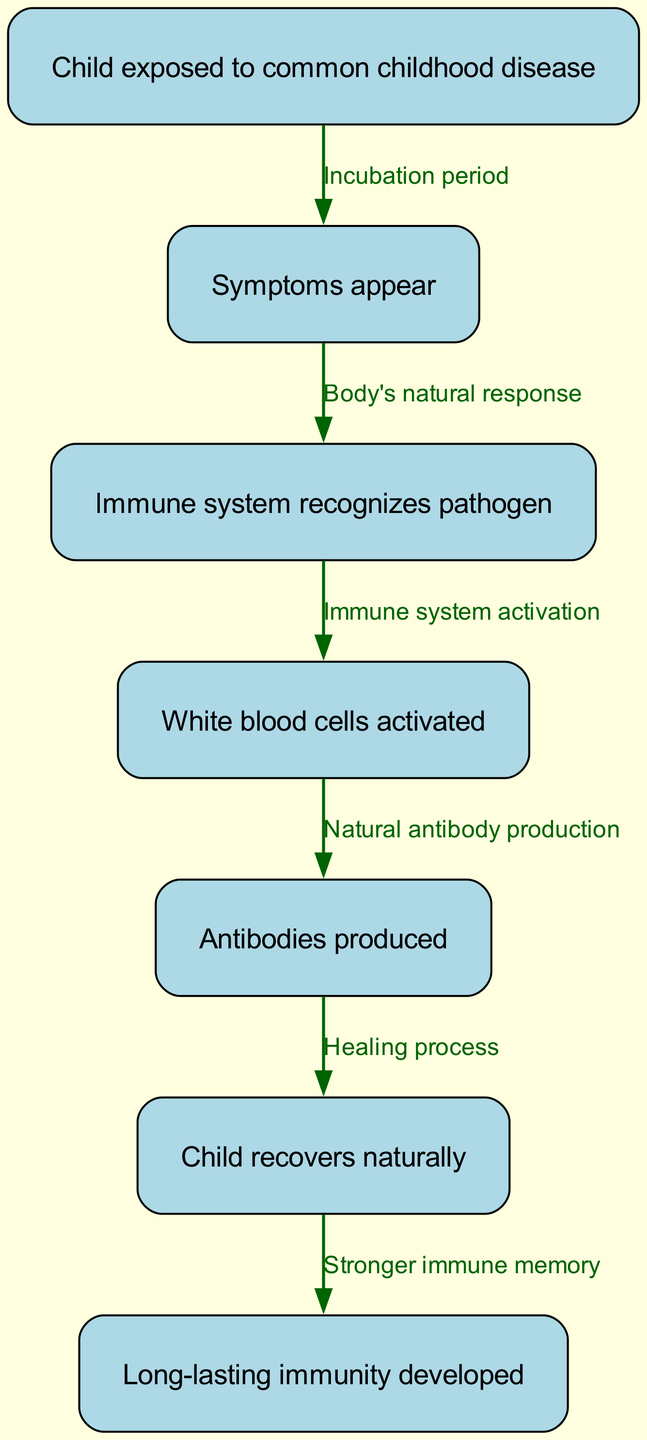What is the first step in the natural immunity development process? The first step is when the child is exposed to a common childhood disease, which is represented by the first node in the diagram.
Answer: Child exposed to common childhood disease How many nodes are in the diagram? By counting the distinct boxes (nodes) in the diagram, we find a total of seven nodes that represent different stages in the immune response process.
Answer: 7 What follows after symptoms appear? After symptoms appear, the body's natural response occurs, leading to the immune system recognizing the pathogen, which is the next step in the flow from the second to the third node.
Answer: Immune system recognizes pathogen What does the activation of white blood cells lead to? The activation of white blood cells results in the production of antibodies, as indicated by the direct flow in the diagram from the fourth node to the fifth node.
Answer: Antibodies produced What process occurs after the child recovers? After the child recovers naturally, a stronger immune memory is developed, indicated by the transition from the sixth node to the seventh node in the diagram.
Answer: Stronger immune memory What is the relationship between the activation of white blood cells and antibody production? The relationship is that the activation of white blood cells leads to the production of antibodies, as shown by the direct connection between nodes four and five in the diagram.
Answer: Natural antibody production What stage follows the immune system recognizing the pathogen? The stage that follows the immune system recognizing the pathogen is the activation of white blood cells, represented by the edges connecting the third node to the fourth node.
Answer: White blood cells activated What happens during the healing process? The healing process includes the production of antibodies, which occurs after white blood cells are activated, leading to the child's natural recovery from the disease.
Answer: Child recovers naturally 